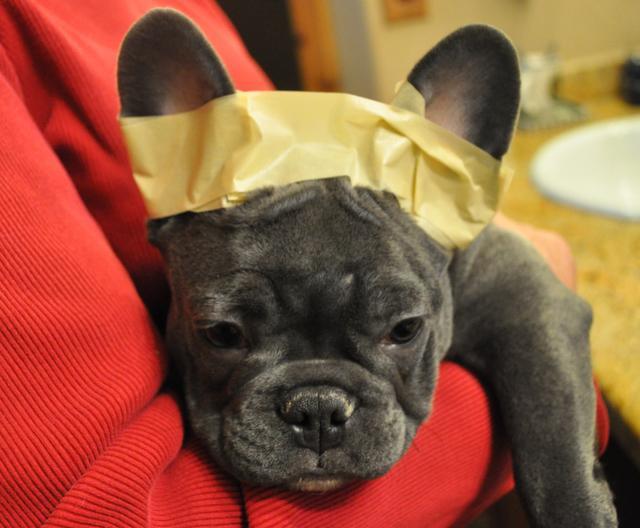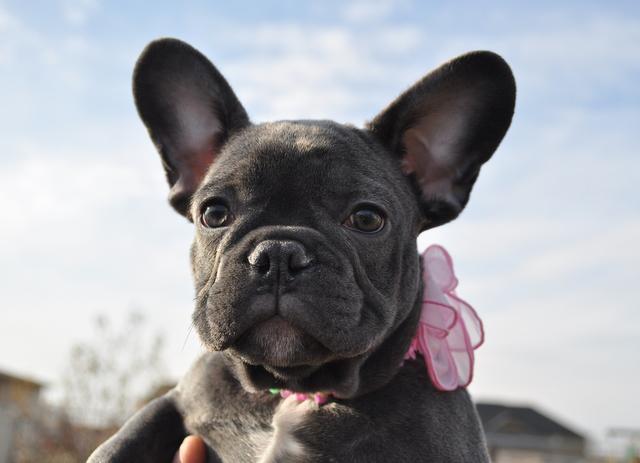The first image is the image on the left, the second image is the image on the right. Evaluate the accuracy of this statement regarding the images: "The dog in the left image has tape on its ears.". Is it true? Answer yes or no. Yes. The first image is the image on the left, the second image is the image on the right. Considering the images on both sides, is "At least one image shows a dark-furred dog with masking tape around at least one ear." valid? Answer yes or no. Yes. 